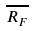Convert formula to latex. <formula><loc_0><loc_0><loc_500><loc_500>\overline { R _ { F } }</formula> 